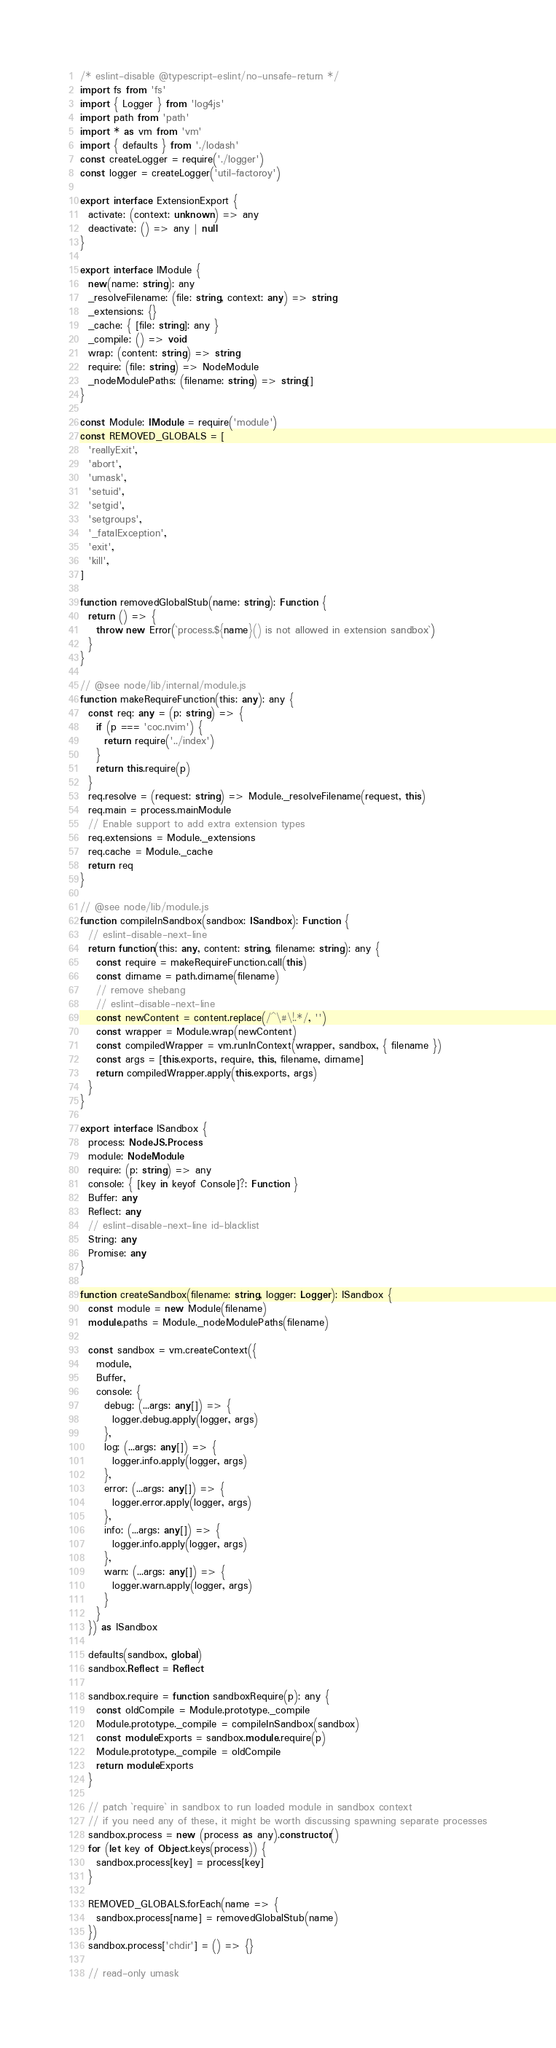<code> <loc_0><loc_0><loc_500><loc_500><_TypeScript_>/* eslint-disable @typescript-eslint/no-unsafe-return */
import fs from 'fs'
import { Logger } from 'log4js'
import path from 'path'
import * as vm from 'vm'
import { defaults } from './lodash'
const createLogger = require('./logger')
const logger = createLogger('util-factoroy')

export interface ExtensionExport {
  activate: (context: unknown) => any
  deactivate: () => any | null
}

export interface IModule {
  new(name: string): any
  _resolveFilename: (file: string, context: any) => string
  _extensions: {}
  _cache: { [file: string]: any }
  _compile: () => void
  wrap: (content: string) => string
  require: (file: string) => NodeModule
  _nodeModulePaths: (filename: string) => string[]
}

const Module: IModule = require('module')
const REMOVED_GLOBALS = [
  'reallyExit',
  'abort',
  'umask',
  'setuid',
  'setgid',
  'setgroups',
  '_fatalException',
  'exit',
  'kill',
]

function removedGlobalStub(name: string): Function {
  return () => {
    throw new Error(`process.${name}() is not allowed in extension sandbox`)
  }
}

// @see node/lib/internal/module.js
function makeRequireFunction(this: any): any {
  const req: any = (p: string) => {
    if (p === 'coc.nvim') {
      return require('../index')
    }
    return this.require(p)
  }
  req.resolve = (request: string) => Module._resolveFilename(request, this)
  req.main = process.mainModule
  // Enable support to add extra extension types
  req.extensions = Module._extensions
  req.cache = Module._cache
  return req
}

// @see node/lib/module.js
function compileInSandbox(sandbox: ISandbox): Function {
  // eslint-disable-next-line
  return function(this: any, content: string, filename: string): any {
    const require = makeRequireFunction.call(this)
    const dirname = path.dirname(filename)
    // remove shebang
    // eslint-disable-next-line
    const newContent = content.replace(/^\#\!.*/, '')
    const wrapper = Module.wrap(newContent)
    const compiledWrapper = vm.runInContext(wrapper, sandbox, { filename })
    const args = [this.exports, require, this, filename, dirname]
    return compiledWrapper.apply(this.exports, args)
  }
}

export interface ISandbox {
  process: NodeJS.Process
  module: NodeModule
  require: (p: string) => any
  console: { [key in keyof Console]?: Function }
  Buffer: any
  Reflect: any
  // eslint-disable-next-line id-blacklist
  String: any
  Promise: any
}

function createSandbox(filename: string, logger: Logger): ISandbox {
  const module = new Module(filename)
  module.paths = Module._nodeModulePaths(filename)

  const sandbox = vm.createContext({
    module,
    Buffer,
    console: {
      debug: (...args: any[]) => {
        logger.debug.apply(logger, args)
      },
      log: (...args: any[]) => {
        logger.info.apply(logger, args)
      },
      error: (...args: any[]) => {
        logger.error.apply(logger, args)
      },
      info: (...args: any[]) => {
        logger.info.apply(logger, args)
      },
      warn: (...args: any[]) => {
        logger.warn.apply(logger, args)
      }
    }
  }) as ISandbox

  defaults(sandbox, global)
  sandbox.Reflect = Reflect

  sandbox.require = function sandboxRequire(p): any {
    const oldCompile = Module.prototype._compile
    Module.prototype._compile = compileInSandbox(sandbox)
    const moduleExports = sandbox.module.require(p)
    Module.prototype._compile = oldCompile
    return moduleExports
  }

  // patch `require` in sandbox to run loaded module in sandbox context
  // if you need any of these, it might be worth discussing spawning separate processes
  sandbox.process = new (process as any).constructor()
  for (let key of Object.keys(process)) {
    sandbox.process[key] = process[key]
  }

  REMOVED_GLOBALS.forEach(name => {
    sandbox.process[name] = removedGlobalStub(name)
  })
  sandbox.process['chdir'] = () => {}

  // read-only umask</code> 